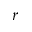Convert formula to latex. <formula><loc_0><loc_0><loc_500><loc_500>r</formula> 